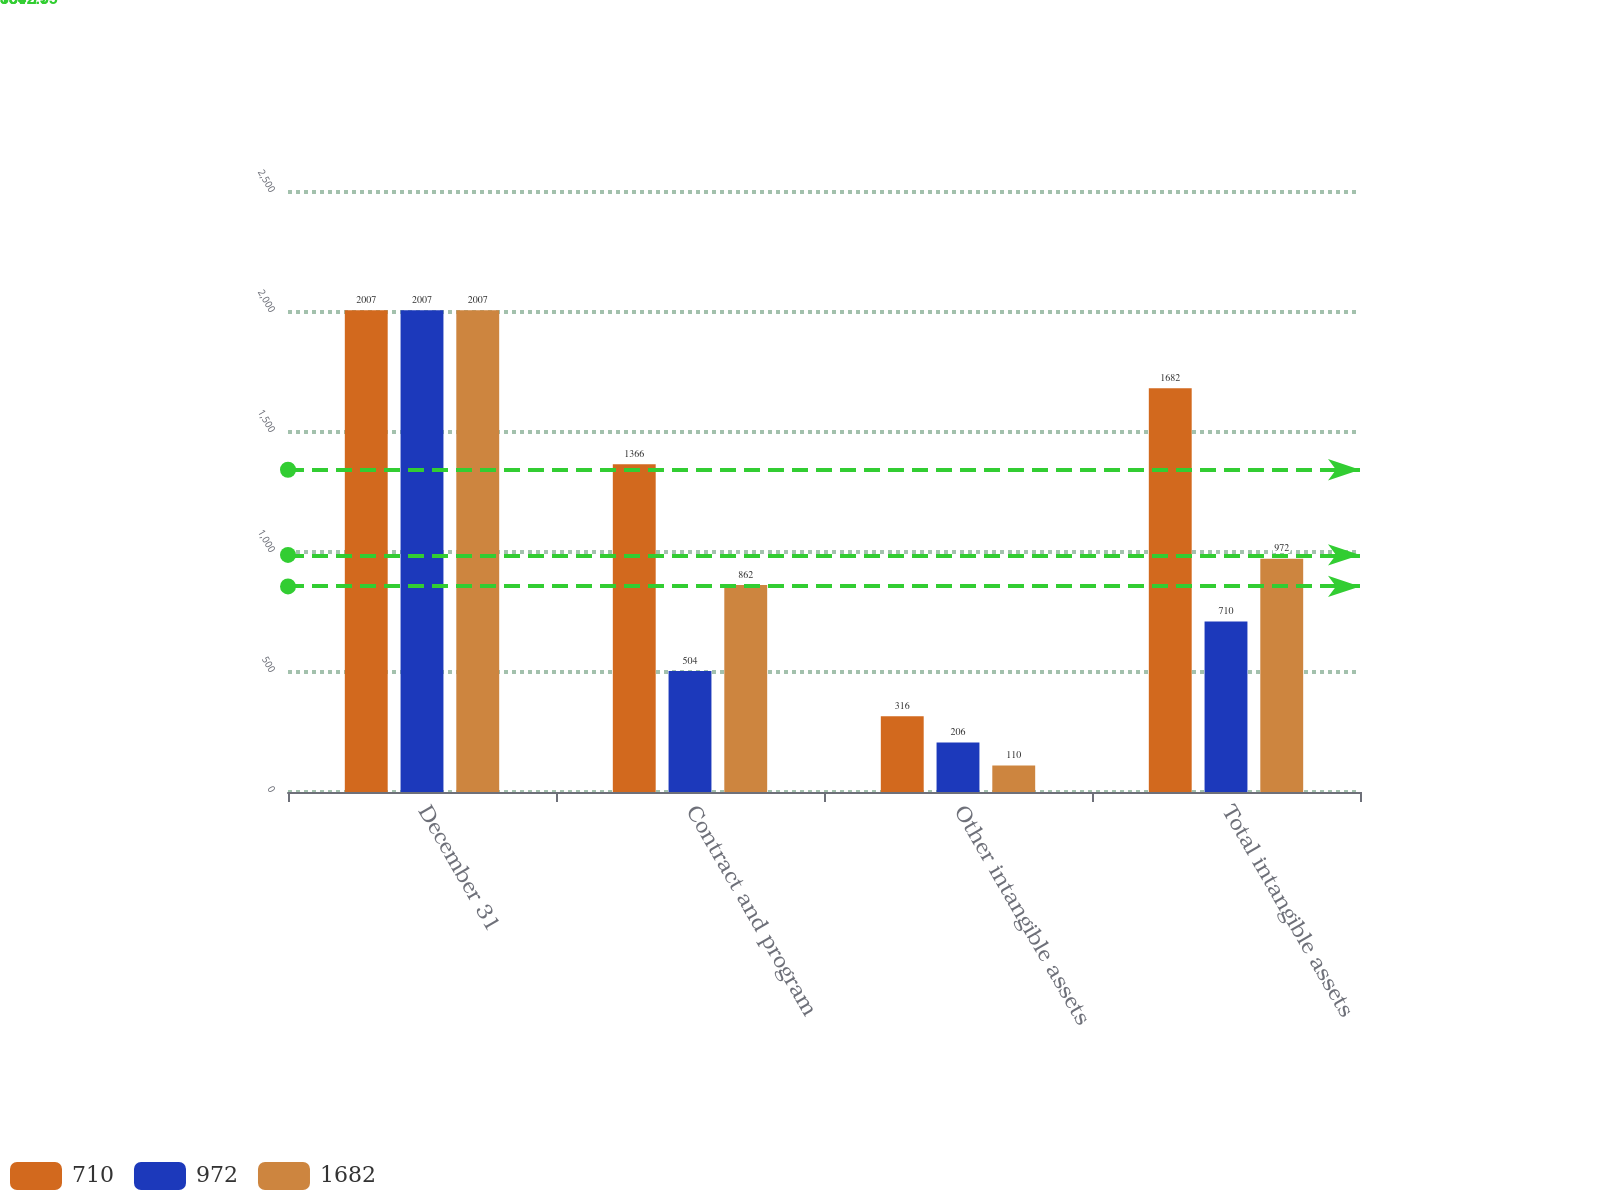Convert chart to OTSL. <chart><loc_0><loc_0><loc_500><loc_500><stacked_bar_chart><ecel><fcel>December 31<fcel>Contract and program<fcel>Other intangible assets<fcel>Total intangible assets<nl><fcel>710<fcel>2007<fcel>1366<fcel>316<fcel>1682<nl><fcel>972<fcel>2007<fcel>504<fcel>206<fcel>710<nl><fcel>1682<fcel>2007<fcel>862<fcel>110<fcel>972<nl></chart> 